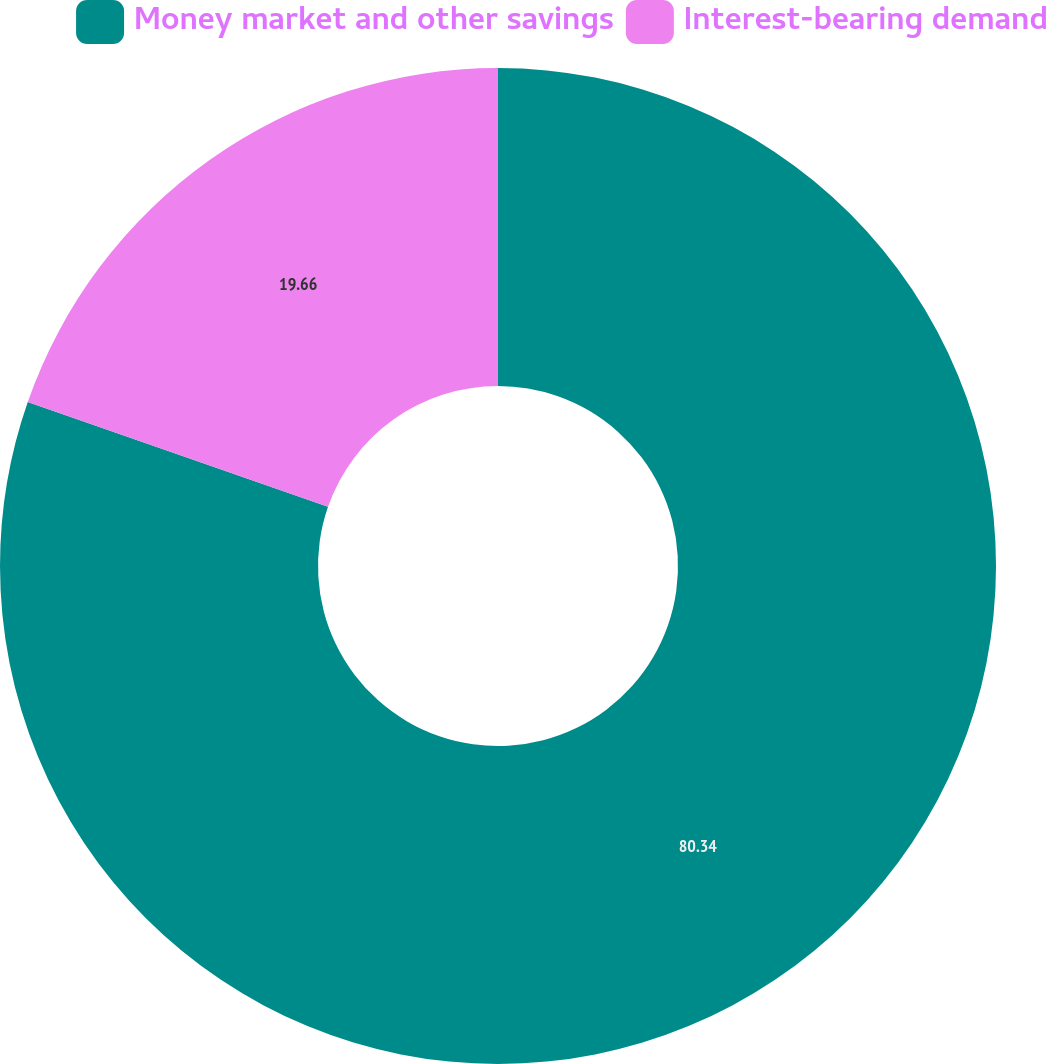<chart> <loc_0><loc_0><loc_500><loc_500><pie_chart><fcel>Money market and other savings<fcel>Interest-bearing demand<nl><fcel>80.34%<fcel>19.66%<nl></chart> 